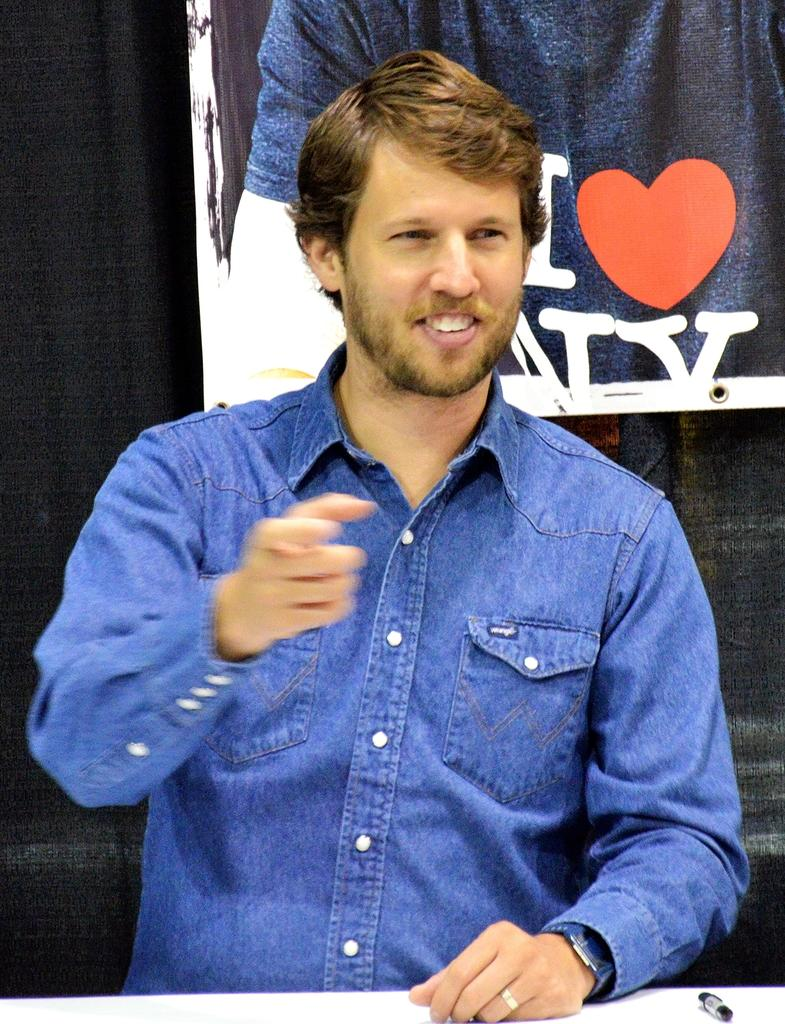What is the main subject of the image? There is a person standing in the image. Where is the person standing in relation to other objects? The person is standing in front of a table. What object can be seen on top of the table? There is a pen on top of the table. What is visible behind the person? There is a banner behind the person. What type of pail is being used by the person's father in the image? There is no father or pail present in the image. Can you describe the edge of the table in the image? The facts provided do not mention the edge of the table, so it cannot be described. 